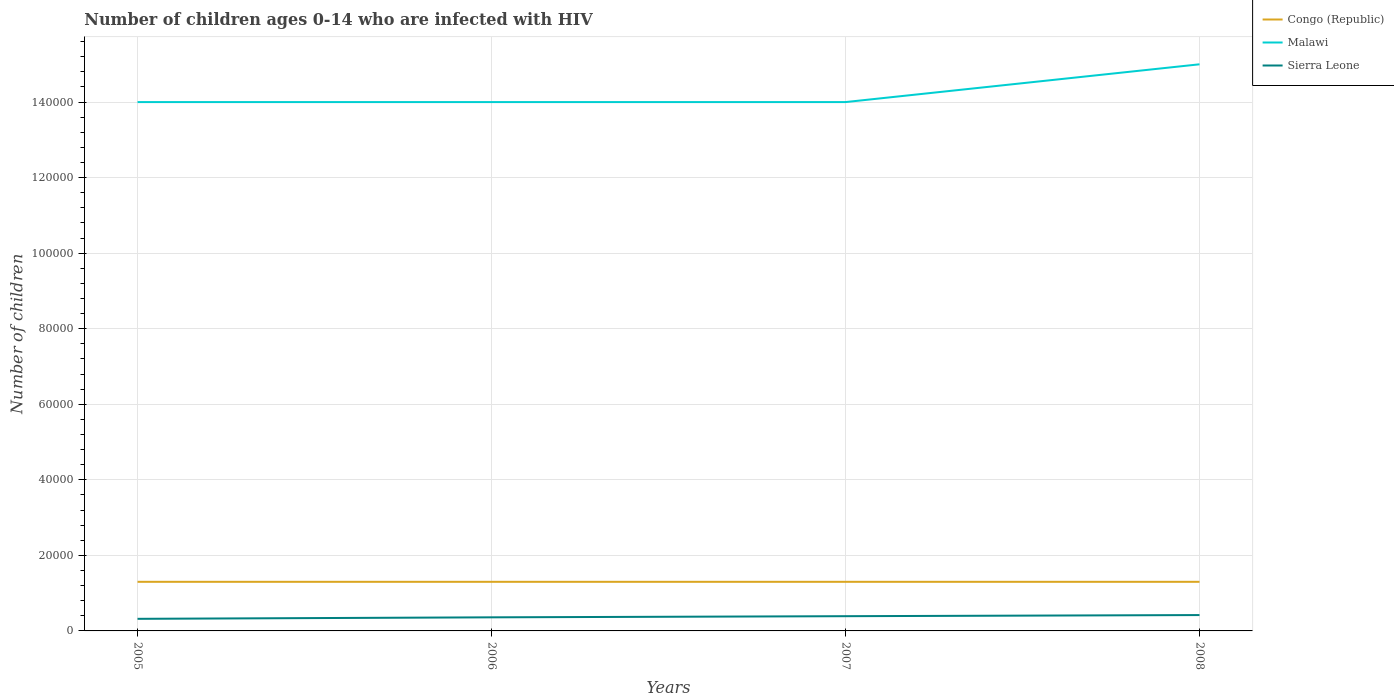How many different coloured lines are there?
Your answer should be very brief. 3. Does the line corresponding to Malawi intersect with the line corresponding to Congo (Republic)?
Your answer should be very brief. No. Is the number of lines equal to the number of legend labels?
Make the answer very short. Yes. Across all years, what is the maximum number of HIV infected children in Sierra Leone?
Your answer should be compact. 3200. In which year was the number of HIV infected children in Malawi maximum?
Ensure brevity in your answer.  2005. What is the total number of HIV infected children in Congo (Republic) in the graph?
Provide a short and direct response. 0. What is the difference between the highest and the second highest number of HIV infected children in Malawi?
Provide a succinct answer. 10000. What is the difference between the highest and the lowest number of HIV infected children in Congo (Republic)?
Keep it short and to the point. 0. Is the number of HIV infected children in Malawi strictly greater than the number of HIV infected children in Congo (Republic) over the years?
Give a very brief answer. No. How many lines are there?
Keep it short and to the point. 3. How many years are there in the graph?
Provide a succinct answer. 4. Are the values on the major ticks of Y-axis written in scientific E-notation?
Provide a short and direct response. No. Does the graph contain any zero values?
Offer a terse response. No. Where does the legend appear in the graph?
Your answer should be compact. Top right. What is the title of the graph?
Your response must be concise. Number of children ages 0-14 who are infected with HIV. Does "Portugal" appear as one of the legend labels in the graph?
Provide a succinct answer. No. What is the label or title of the Y-axis?
Offer a very short reply. Number of children. What is the Number of children in Congo (Republic) in 2005?
Your answer should be compact. 1.30e+04. What is the Number of children of Malawi in 2005?
Ensure brevity in your answer.  1.40e+05. What is the Number of children of Sierra Leone in 2005?
Give a very brief answer. 3200. What is the Number of children in Congo (Republic) in 2006?
Give a very brief answer. 1.30e+04. What is the Number of children of Malawi in 2006?
Offer a terse response. 1.40e+05. What is the Number of children of Sierra Leone in 2006?
Offer a terse response. 3600. What is the Number of children of Congo (Republic) in 2007?
Ensure brevity in your answer.  1.30e+04. What is the Number of children of Sierra Leone in 2007?
Your answer should be compact. 3900. What is the Number of children of Congo (Republic) in 2008?
Your response must be concise. 1.30e+04. What is the Number of children in Sierra Leone in 2008?
Your answer should be very brief. 4200. Across all years, what is the maximum Number of children of Congo (Republic)?
Your response must be concise. 1.30e+04. Across all years, what is the maximum Number of children of Sierra Leone?
Offer a terse response. 4200. Across all years, what is the minimum Number of children of Congo (Republic)?
Offer a terse response. 1.30e+04. Across all years, what is the minimum Number of children in Sierra Leone?
Keep it short and to the point. 3200. What is the total Number of children in Congo (Republic) in the graph?
Provide a short and direct response. 5.20e+04. What is the total Number of children in Malawi in the graph?
Your answer should be compact. 5.70e+05. What is the total Number of children in Sierra Leone in the graph?
Provide a short and direct response. 1.49e+04. What is the difference between the Number of children in Congo (Republic) in 2005 and that in 2006?
Your response must be concise. 0. What is the difference between the Number of children of Malawi in 2005 and that in 2006?
Give a very brief answer. 0. What is the difference between the Number of children of Sierra Leone in 2005 and that in 2006?
Provide a succinct answer. -400. What is the difference between the Number of children in Malawi in 2005 and that in 2007?
Provide a short and direct response. 0. What is the difference between the Number of children of Sierra Leone in 2005 and that in 2007?
Give a very brief answer. -700. What is the difference between the Number of children in Congo (Republic) in 2005 and that in 2008?
Offer a terse response. 0. What is the difference between the Number of children in Malawi in 2005 and that in 2008?
Your answer should be very brief. -10000. What is the difference between the Number of children of Sierra Leone in 2005 and that in 2008?
Your answer should be compact. -1000. What is the difference between the Number of children of Congo (Republic) in 2006 and that in 2007?
Your answer should be compact. 0. What is the difference between the Number of children of Malawi in 2006 and that in 2007?
Your answer should be very brief. 0. What is the difference between the Number of children of Sierra Leone in 2006 and that in 2007?
Your response must be concise. -300. What is the difference between the Number of children in Congo (Republic) in 2006 and that in 2008?
Keep it short and to the point. 0. What is the difference between the Number of children of Sierra Leone in 2006 and that in 2008?
Offer a terse response. -600. What is the difference between the Number of children in Congo (Republic) in 2007 and that in 2008?
Your answer should be compact. 0. What is the difference between the Number of children in Malawi in 2007 and that in 2008?
Your response must be concise. -10000. What is the difference between the Number of children in Sierra Leone in 2007 and that in 2008?
Offer a very short reply. -300. What is the difference between the Number of children of Congo (Republic) in 2005 and the Number of children of Malawi in 2006?
Ensure brevity in your answer.  -1.27e+05. What is the difference between the Number of children of Congo (Republic) in 2005 and the Number of children of Sierra Leone in 2006?
Provide a succinct answer. 9400. What is the difference between the Number of children of Malawi in 2005 and the Number of children of Sierra Leone in 2006?
Give a very brief answer. 1.36e+05. What is the difference between the Number of children of Congo (Republic) in 2005 and the Number of children of Malawi in 2007?
Offer a very short reply. -1.27e+05. What is the difference between the Number of children of Congo (Republic) in 2005 and the Number of children of Sierra Leone in 2007?
Provide a succinct answer. 9100. What is the difference between the Number of children of Malawi in 2005 and the Number of children of Sierra Leone in 2007?
Your answer should be compact. 1.36e+05. What is the difference between the Number of children in Congo (Republic) in 2005 and the Number of children in Malawi in 2008?
Your answer should be very brief. -1.37e+05. What is the difference between the Number of children of Congo (Republic) in 2005 and the Number of children of Sierra Leone in 2008?
Offer a very short reply. 8800. What is the difference between the Number of children of Malawi in 2005 and the Number of children of Sierra Leone in 2008?
Offer a very short reply. 1.36e+05. What is the difference between the Number of children of Congo (Republic) in 2006 and the Number of children of Malawi in 2007?
Your answer should be compact. -1.27e+05. What is the difference between the Number of children of Congo (Republic) in 2006 and the Number of children of Sierra Leone in 2007?
Your answer should be compact. 9100. What is the difference between the Number of children of Malawi in 2006 and the Number of children of Sierra Leone in 2007?
Provide a succinct answer. 1.36e+05. What is the difference between the Number of children in Congo (Republic) in 2006 and the Number of children in Malawi in 2008?
Your answer should be very brief. -1.37e+05. What is the difference between the Number of children of Congo (Republic) in 2006 and the Number of children of Sierra Leone in 2008?
Your response must be concise. 8800. What is the difference between the Number of children in Malawi in 2006 and the Number of children in Sierra Leone in 2008?
Your answer should be very brief. 1.36e+05. What is the difference between the Number of children in Congo (Republic) in 2007 and the Number of children in Malawi in 2008?
Your response must be concise. -1.37e+05. What is the difference between the Number of children of Congo (Republic) in 2007 and the Number of children of Sierra Leone in 2008?
Your answer should be compact. 8800. What is the difference between the Number of children in Malawi in 2007 and the Number of children in Sierra Leone in 2008?
Make the answer very short. 1.36e+05. What is the average Number of children in Congo (Republic) per year?
Your answer should be compact. 1.30e+04. What is the average Number of children of Malawi per year?
Offer a very short reply. 1.42e+05. What is the average Number of children in Sierra Leone per year?
Offer a terse response. 3725. In the year 2005, what is the difference between the Number of children of Congo (Republic) and Number of children of Malawi?
Provide a succinct answer. -1.27e+05. In the year 2005, what is the difference between the Number of children of Congo (Republic) and Number of children of Sierra Leone?
Give a very brief answer. 9800. In the year 2005, what is the difference between the Number of children in Malawi and Number of children in Sierra Leone?
Your answer should be very brief. 1.37e+05. In the year 2006, what is the difference between the Number of children in Congo (Republic) and Number of children in Malawi?
Give a very brief answer. -1.27e+05. In the year 2006, what is the difference between the Number of children in Congo (Republic) and Number of children in Sierra Leone?
Provide a short and direct response. 9400. In the year 2006, what is the difference between the Number of children in Malawi and Number of children in Sierra Leone?
Keep it short and to the point. 1.36e+05. In the year 2007, what is the difference between the Number of children in Congo (Republic) and Number of children in Malawi?
Ensure brevity in your answer.  -1.27e+05. In the year 2007, what is the difference between the Number of children in Congo (Republic) and Number of children in Sierra Leone?
Your response must be concise. 9100. In the year 2007, what is the difference between the Number of children in Malawi and Number of children in Sierra Leone?
Your answer should be compact. 1.36e+05. In the year 2008, what is the difference between the Number of children of Congo (Republic) and Number of children of Malawi?
Offer a very short reply. -1.37e+05. In the year 2008, what is the difference between the Number of children of Congo (Republic) and Number of children of Sierra Leone?
Make the answer very short. 8800. In the year 2008, what is the difference between the Number of children in Malawi and Number of children in Sierra Leone?
Your answer should be very brief. 1.46e+05. What is the ratio of the Number of children in Congo (Republic) in 2005 to that in 2006?
Your response must be concise. 1. What is the ratio of the Number of children in Congo (Republic) in 2005 to that in 2007?
Keep it short and to the point. 1. What is the ratio of the Number of children in Malawi in 2005 to that in 2007?
Give a very brief answer. 1. What is the ratio of the Number of children of Sierra Leone in 2005 to that in 2007?
Your response must be concise. 0.82. What is the ratio of the Number of children in Congo (Republic) in 2005 to that in 2008?
Make the answer very short. 1. What is the ratio of the Number of children of Malawi in 2005 to that in 2008?
Offer a terse response. 0.93. What is the ratio of the Number of children of Sierra Leone in 2005 to that in 2008?
Keep it short and to the point. 0.76. What is the ratio of the Number of children in Sierra Leone in 2006 to that in 2007?
Provide a succinct answer. 0.92. What is the ratio of the Number of children of Congo (Republic) in 2006 to that in 2008?
Your answer should be compact. 1. What is the ratio of the Number of children of Sierra Leone in 2006 to that in 2008?
Make the answer very short. 0.86. What is the difference between the highest and the second highest Number of children in Congo (Republic)?
Offer a very short reply. 0. What is the difference between the highest and the second highest Number of children in Sierra Leone?
Ensure brevity in your answer.  300. What is the difference between the highest and the lowest Number of children in Sierra Leone?
Your response must be concise. 1000. 